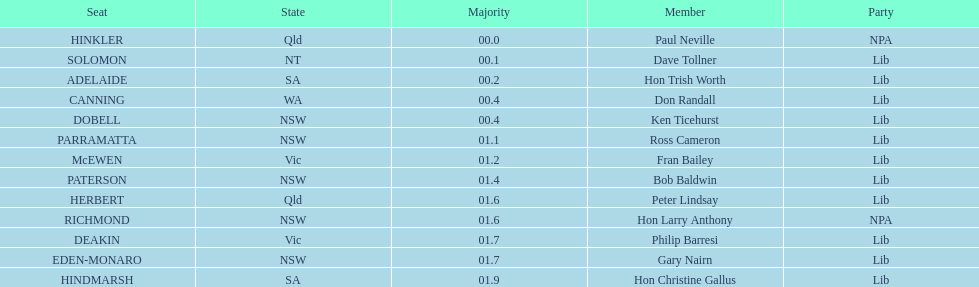What was the total majority that the dobell seat had? 00.4. 